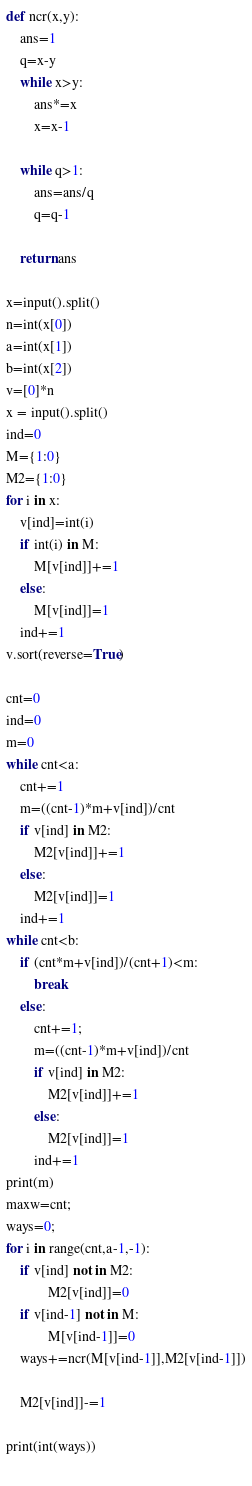Convert code to text. <code><loc_0><loc_0><loc_500><loc_500><_Python_>def ncr(x,y):
	ans=1
	q=x-y
	while x>y:
		ans*=x
		x=x-1
	
	while q>1:
		ans=ans/q
		q=q-1
	
	return ans

x=input().split()
n=int(x[0])
a=int(x[1])
b=int(x[2])
v=[0]*n
x = input().split()
ind=0
M={1:0}
M2={1:0}
for i in x:
	v[ind]=int(i)
	if int(i) in M:
		M[v[ind]]+=1
	else:
		M[v[ind]]=1
	ind+=1
v.sort(reverse=True)

cnt=0
ind=0
m=0
while cnt<a:
	cnt+=1
	m=((cnt-1)*m+v[ind])/cnt
	if v[ind] in M2:
		M2[v[ind]]+=1
	else:
		M2[v[ind]]=1
	ind+=1
while cnt<b:
	if (cnt*m+v[ind])/(cnt+1)<m:
		break
	else:
		cnt+=1;
		m=((cnt-1)*m+v[ind])/cnt
		if v[ind] in M2:
			M2[v[ind]]+=1
		else:
			M2[v[ind]]=1
		ind+=1
print(m)
maxw=cnt;
ways=0;
for i in range(cnt,a-1,-1):
	if v[ind] not in M2:
			M2[v[ind]]=0
	if v[ind-1] not in M:
			M[v[ind-1]]=0
	ways+=ncr(M[v[ind-1]],M2[v[ind-1]])
	
	M2[v[ind]]-=1

print(int(ways))
	</code> 